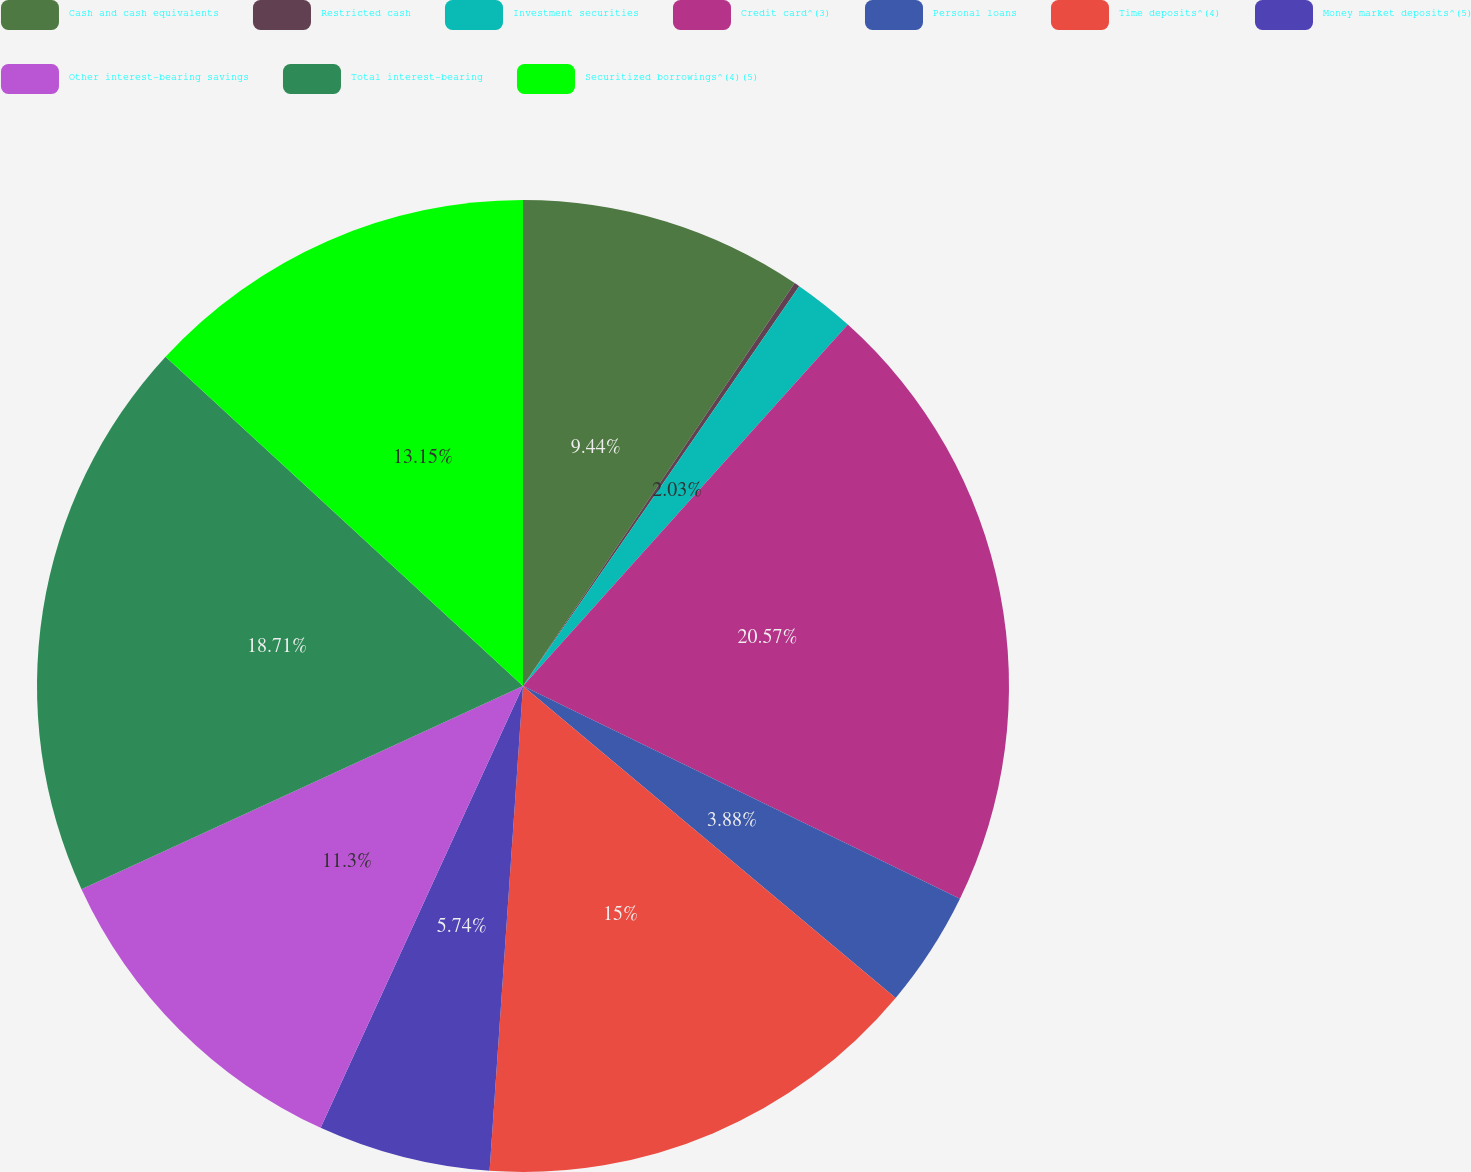Convert chart. <chart><loc_0><loc_0><loc_500><loc_500><pie_chart><fcel>Cash and cash equivalents<fcel>Restricted cash<fcel>Investment securities<fcel>Credit card^(3)<fcel>Personal loans<fcel>Time deposits^(4)<fcel>Money market deposits^(5)<fcel>Other interest-bearing savings<fcel>Total interest-bearing<fcel>Securitized borrowings^(4)(5)<nl><fcel>9.44%<fcel>0.18%<fcel>2.03%<fcel>20.56%<fcel>3.88%<fcel>15.0%<fcel>5.74%<fcel>11.3%<fcel>18.71%<fcel>13.15%<nl></chart> 